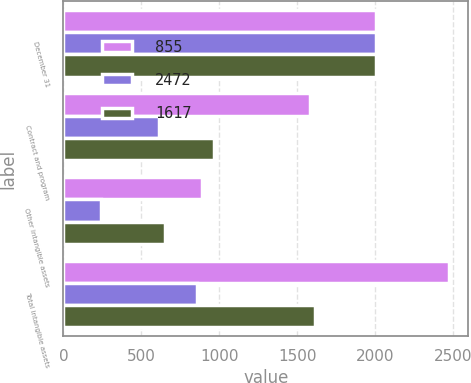Convert chart to OTSL. <chart><loc_0><loc_0><loc_500><loc_500><stacked_bar_chart><ecel><fcel>December 31<fcel>Contract and program<fcel>Other intangible assets<fcel>Total intangible assets<nl><fcel>855<fcel>2008<fcel>1580<fcel>892<fcel>2472<nl><fcel>2472<fcel>2008<fcel>613<fcel>242<fcel>855<nl><fcel>1617<fcel>2008<fcel>967<fcel>650<fcel>1617<nl></chart> 